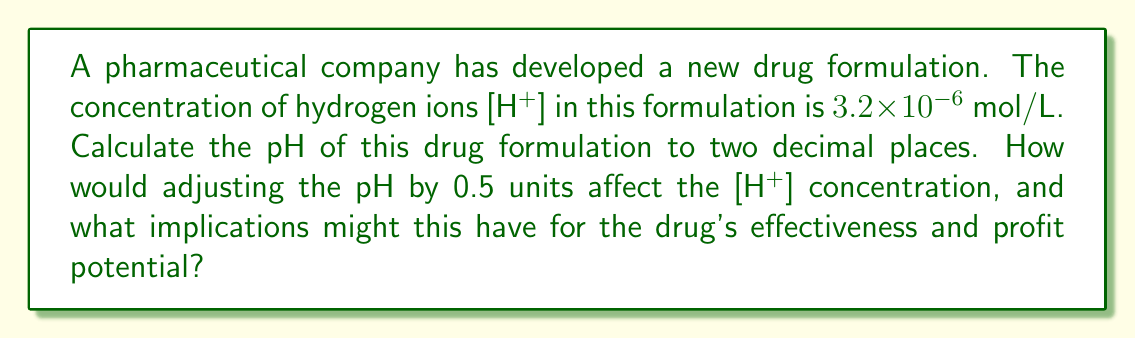Teach me how to tackle this problem. To solve this problem, we'll use the definition of pH and logarithmic properties:

1) The pH is defined as the negative logarithm (base 10) of the hydrogen ion concentration:

   $$ pH = -\log_{10}[H^+] $$

2) Given [H+] = $3.2 \times 10^{-6}$ mol/L, we can substitute this into the equation:

   $$ pH = -\log_{10}(3.2 \times 10^{-6}) $$

3) Using logarithm properties, we can split this:

   $$ pH = -(\log_{10}(3.2) + \log_{10}(10^{-6})) $$

4) Simplify:
   $$ pH = -(0.5051 - 6) = 5.4949 $$

5) Rounding to two decimal places: pH = 5.49

To understand the effect of adjusting pH by 0.5 units:

6) A change of 0.5 pH units means the [H+] will change by a factor of $10^{0.5} \approx 3.16$

7) If pH increases by 0.5, [H+] will decrease by a factor of 3.16
   If pH decreases by 0.5, [H+] will increase by a factor of 3.16

This change could significantly affect the drug's solubility, stability, and how it interacts with the body's systems, potentially impacting its effectiveness. From a profit perspective, optimizing the pH could lead to improved efficacy, longer shelf life, or better absorption, all of which could justify higher pricing or capture larger market share.
Answer: The pH of the drug formulation is 5.49. Adjusting the pH by 0.5 units would change the [H+] concentration by a factor of approximately 3.16, which could significantly impact the drug's properties and potential profitability. 